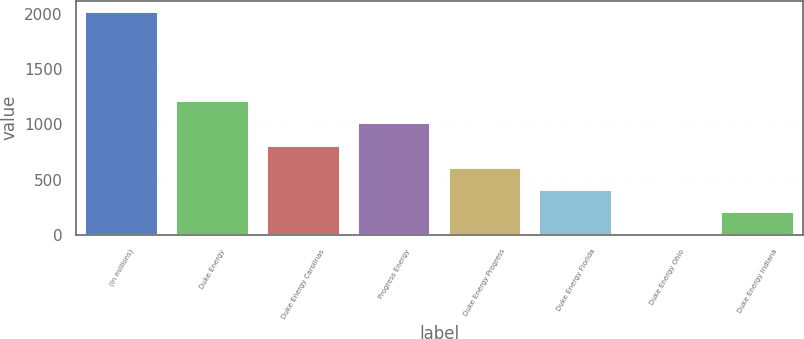Convert chart to OTSL. <chart><loc_0><loc_0><loc_500><loc_500><bar_chart><fcel>(in millions)<fcel>Duke Energy<fcel>Duke Energy Carolinas<fcel>Progress Energy<fcel>Duke Energy Progress<fcel>Duke Energy Florida<fcel>Duke Energy Ohio<fcel>Duke Energy Indiana<nl><fcel>2016<fcel>1210.4<fcel>807.6<fcel>1009<fcel>606.2<fcel>404.8<fcel>2<fcel>203.4<nl></chart> 